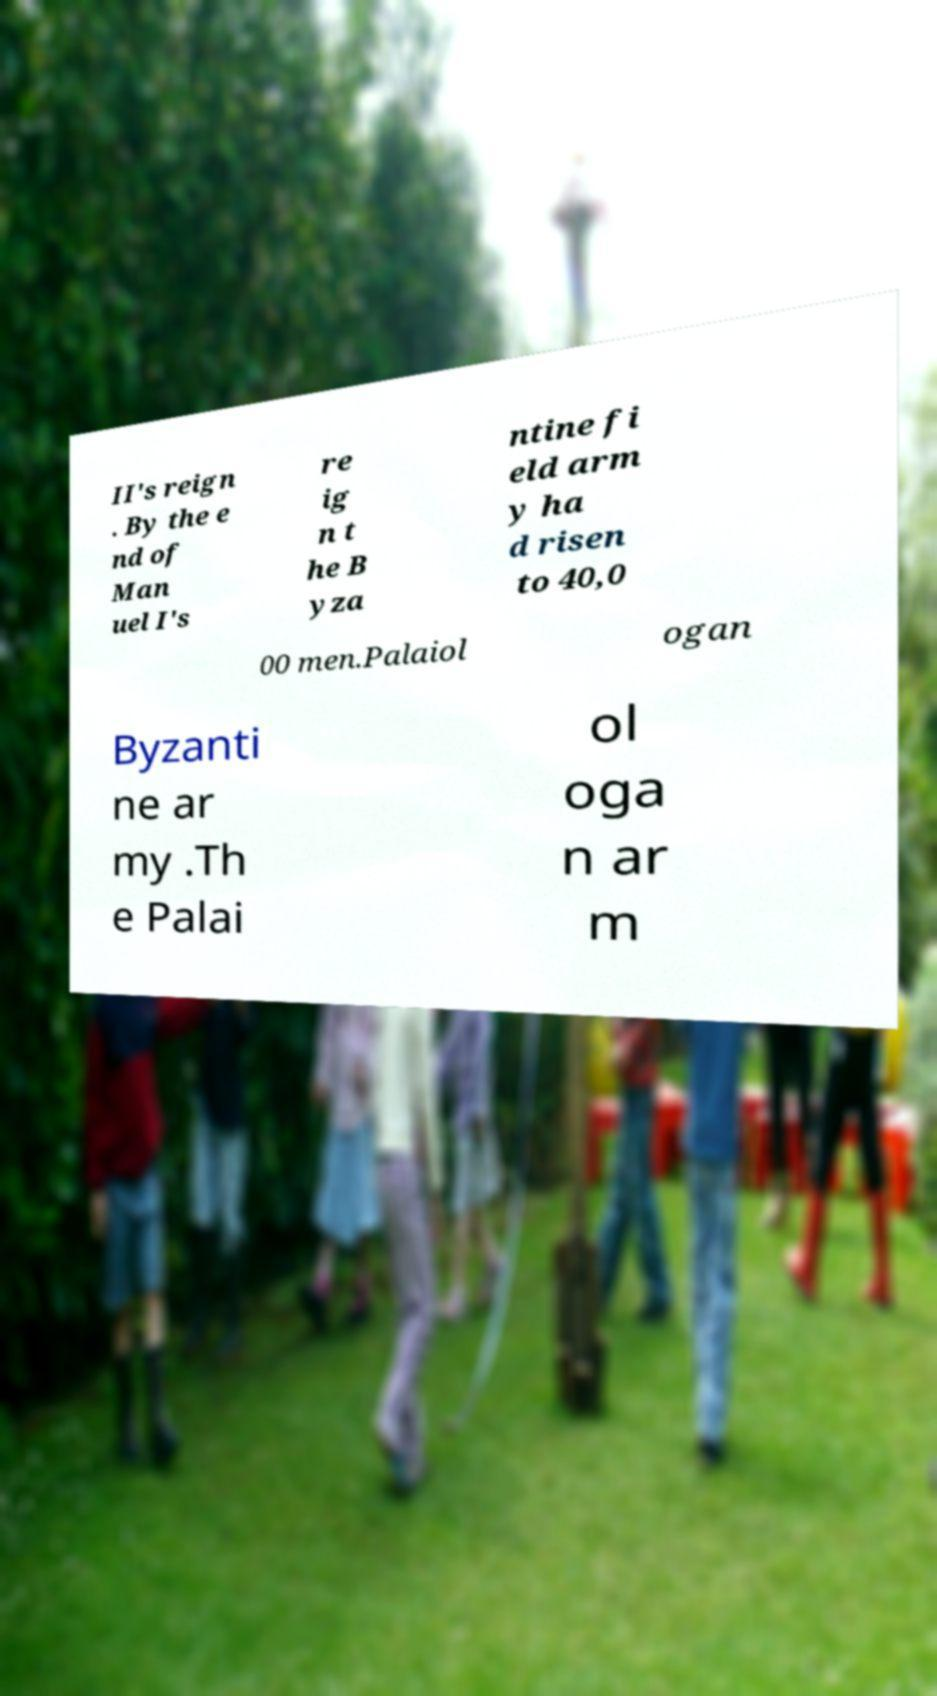For documentation purposes, I need the text within this image transcribed. Could you provide that? II's reign . By the e nd of Man uel I's re ig n t he B yza ntine fi eld arm y ha d risen to 40,0 00 men.Palaiol ogan Byzanti ne ar my .Th e Palai ol oga n ar m 